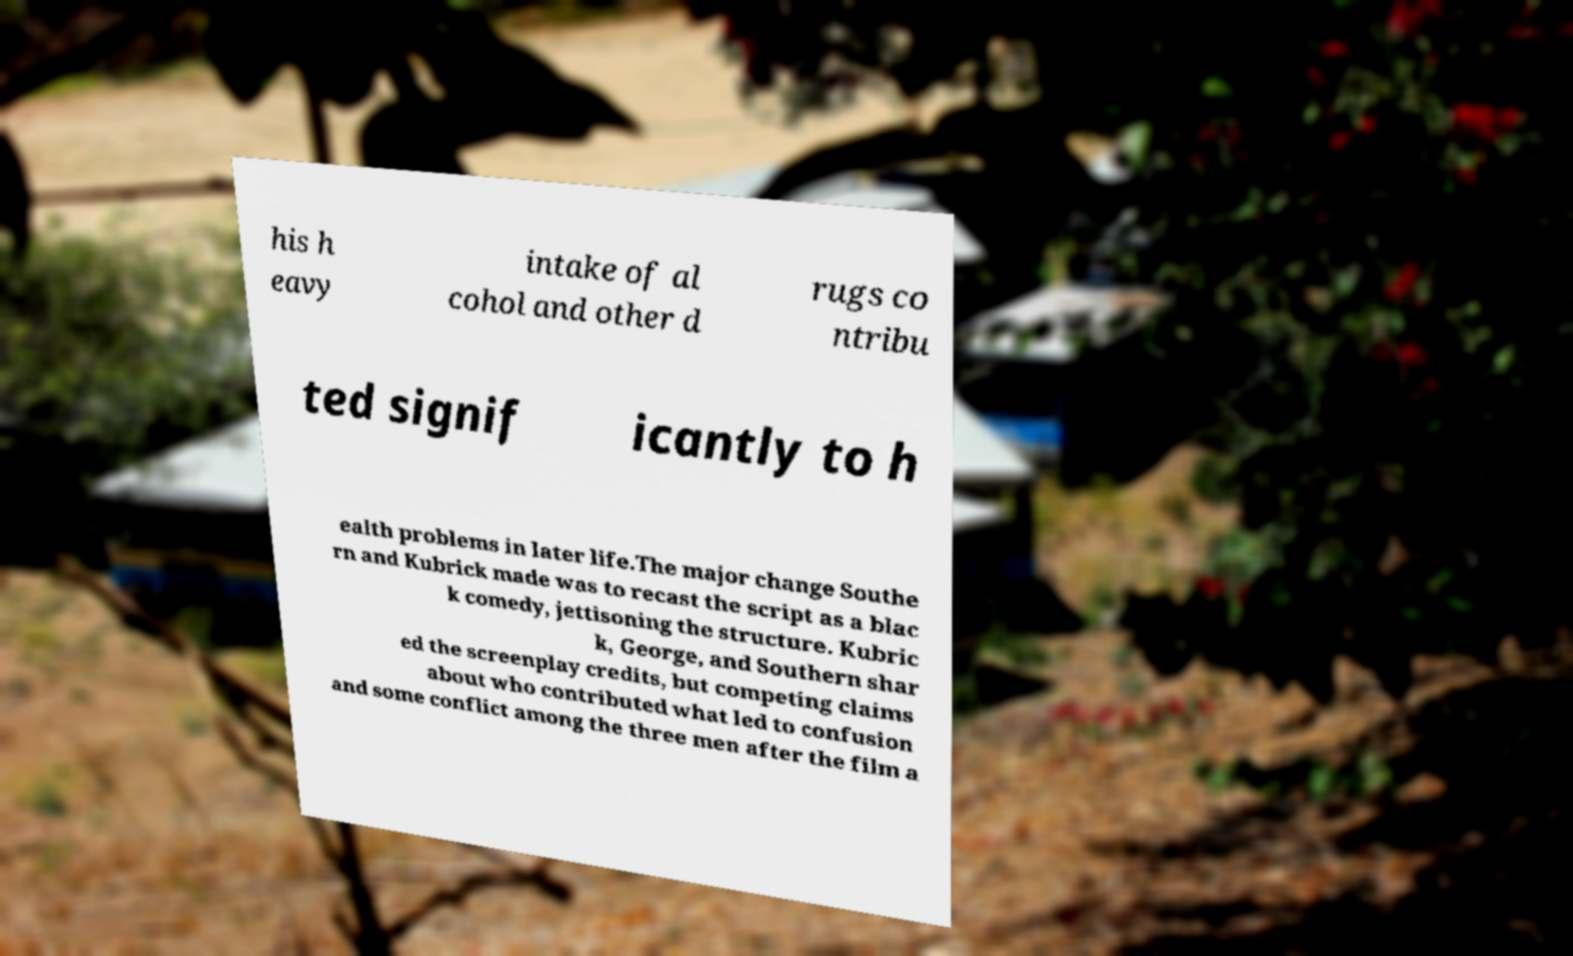What messages or text are displayed in this image? I need them in a readable, typed format. his h eavy intake of al cohol and other d rugs co ntribu ted signif icantly to h ealth problems in later life.The major change Southe rn and Kubrick made was to recast the script as a blac k comedy, jettisoning the structure. Kubric k, George, and Southern shar ed the screenplay credits, but competing claims about who contributed what led to confusion and some conflict among the three men after the film a 